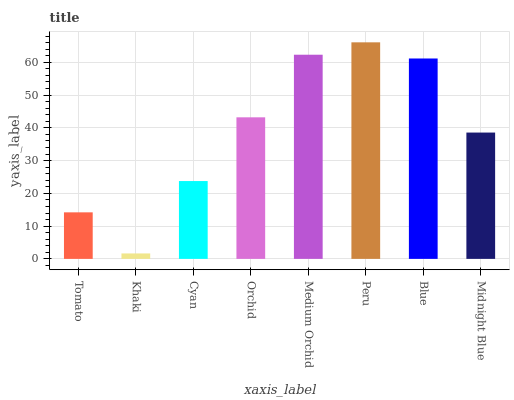Is Khaki the minimum?
Answer yes or no. Yes. Is Peru the maximum?
Answer yes or no. Yes. Is Cyan the minimum?
Answer yes or no. No. Is Cyan the maximum?
Answer yes or no. No. Is Cyan greater than Khaki?
Answer yes or no. Yes. Is Khaki less than Cyan?
Answer yes or no. Yes. Is Khaki greater than Cyan?
Answer yes or no. No. Is Cyan less than Khaki?
Answer yes or no. No. Is Orchid the high median?
Answer yes or no. Yes. Is Midnight Blue the low median?
Answer yes or no. Yes. Is Tomato the high median?
Answer yes or no. No. Is Cyan the low median?
Answer yes or no. No. 